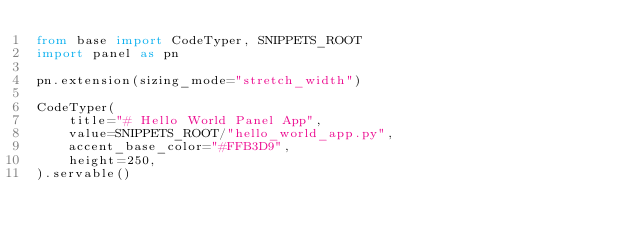<code> <loc_0><loc_0><loc_500><loc_500><_Python_>from base import CodeTyper, SNIPPETS_ROOT
import panel as pn

pn.extension(sizing_mode="stretch_width")

CodeTyper(
    title="# Hello World Panel App",
    value=SNIPPETS_ROOT/"hello_world_app.py",
    accent_base_color="#FFB3D9",
    height=250,
).servable()</code> 